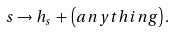Convert formula to latex. <formula><loc_0><loc_0><loc_500><loc_500>s \rightarrow h _ { s } \, + \, \left ( a n y t h i n g \right ) .</formula> 